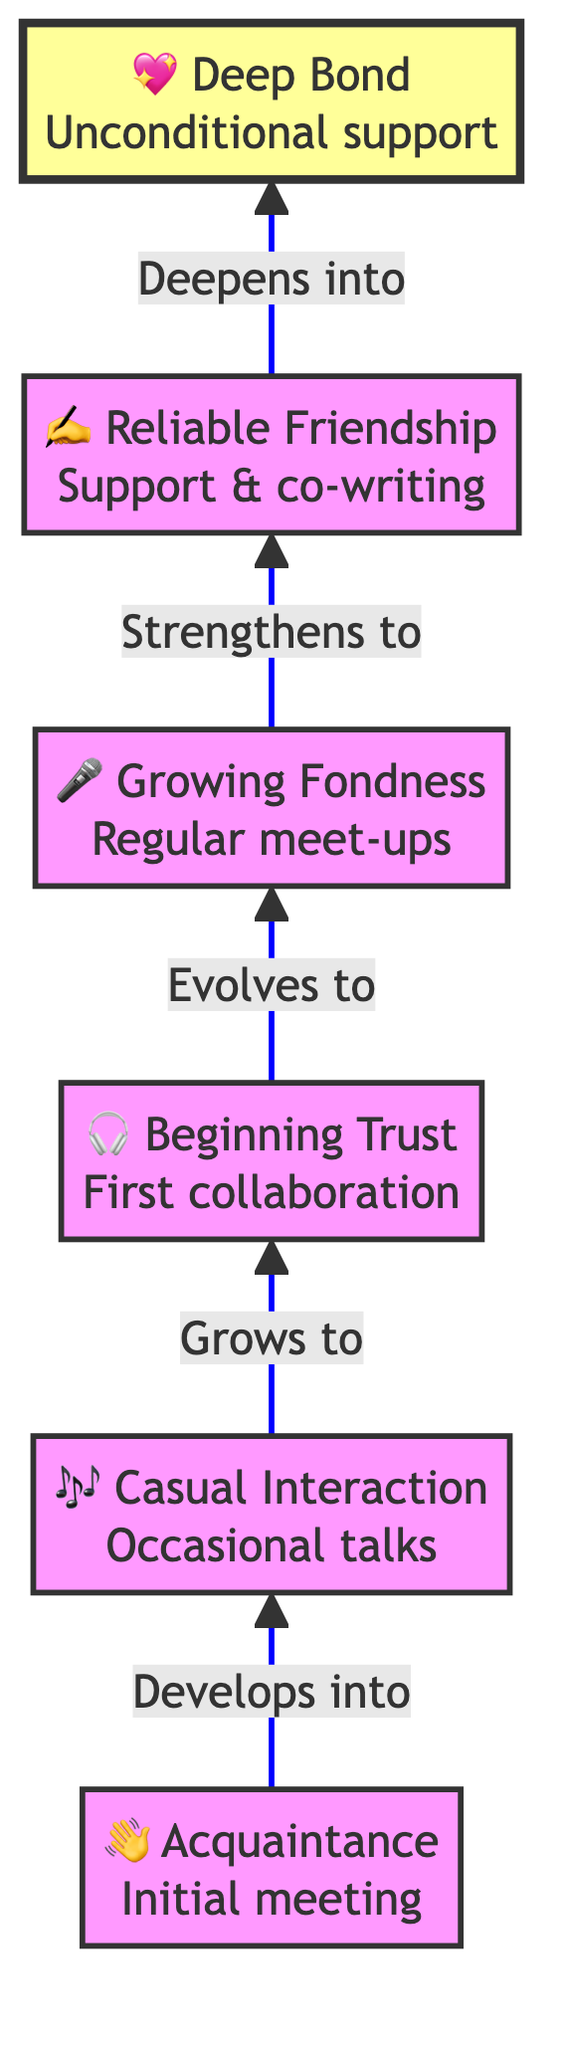What is the highest stage of friendship depicted in the diagram? The highest stage is indicated as the last node in the flow chart, which is labeled "Deep Bond." This is the final level, showing the culmination of the friendship evolution.
Answer: Deep Bond What symbol represents "Growing Fondness"? To identify the symbol for "Growing Fondness," we look at the node corresponding to that stage in the diagram. It displays the microphone symbol ("🎤") as its representation.
Answer: 🎤 How many stages are there in total? We count the number of nodes represented in the diagram for the evolution of friendship stages. There are six distinct stages from Acquaintance to Deep Bond.
Answer: 6 What stage comes after "Casual Interaction"? By examining the flowchart, we see that "Casual Interaction" directly connects to the next node labeled "Beginning Trust," indicating its sequential order in the evolution of friendship.
Answer: Beginning Trust What does "Reliable Friendship" focus on within the context of the diagram? The node for "Reliable Friendship" specifies its focus on providing support during personal milestones and challenges, along with co-writing songs, highlighting the depth of the relationship at that stage.
Answer: Support & co-writing Which two stages indicate a collaboration on music projects? We locate the stages that involve music collaboration. The stages "Beginning Trust" (with the first collaboration) and "Reliable Friendship" (highlighting co-writing songs) both illustrate music project collaboration within the friendship evolution.
Answer: Beginning Trust, Reliable Friendship What is the direct relationship between "Growing Fondness" and "Deep Bond"? The relationship is defined by the directional flow from "Growing Fondness" to "Deep Bond," indicating that as fondness grows, it deepens into an unconditional bond, representing the final evolution in friendship.
Answer: Deepens into What does the arrow signify in the context of this diagram? The arrow in a Bottom to Top Flow Chart indicates the progression and development of friendship stages. As it points upwards, it signifies an evolution and deepening of the relationship from one stage to the next.
Answer: Progression Which level of friendship includes attending concerts together? In the diagram, regular meet-ups and attending concerts together are specifically mentioned under the "Growing Fondness" stage, indicating the social aspects of that level of friendship.
Answer: Growing Fondness 